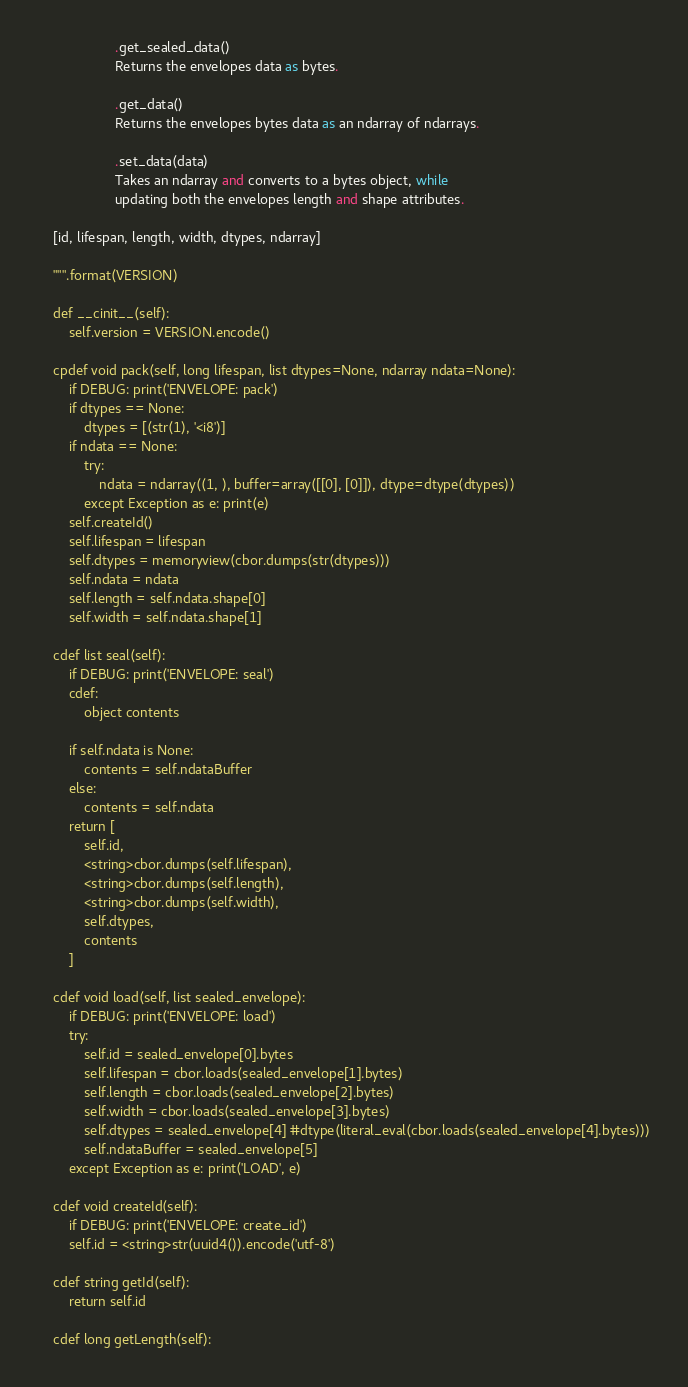<code> <loc_0><loc_0><loc_500><loc_500><_Cython_>                    .get_sealed_data()
                    Returns the envelopes data as bytes.

                    .get_data()
                    Returns the envelopes bytes data as an ndarray of ndarrays.

                    .set_data(data)
                    Takes an ndarray and converts to a bytes object, while 
                    updating both the envelopes length and shape attributes.

    [id, lifespan, length, width, dtypes, ndarray]

    """.format(VERSION)

    def __cinit__(self):
        self.version = VERSION.encode()

    cpdef void pack(self, long lifespan, list dtypes=None, ndarray ndata=None):
        if DEBUG: print('ENVELOPE: pack')
        if dtypes == None:
            dtypes = [(str(1), '<i8')]
        if ndata == None:
            try:
                ndata = ndarray((1, ), buffer=array([[0], [0]]), dtype=dtype(dtypes))
            except Exception as e: print(e)
        self.createId()
        self.lifespan = lifespan
        self.dtypes = memoryview(cbor.dumps(str(dtypes)))
        self.ndata = ndata
        self.length = self.ndata.shape[0]
        self.width = self.ndata.shape[1]

    cdef list seal(self):
        if DEBUG: print('ENVELOPE: seal')
        cdef:
            object contents

        if self.ndata is None:
            contents = self.ndataBuffer
        else:
            contents = self.ndata
        return [
            self.id,
            <string>cbor.dumps(self.lifespan),
            <string>cbor.dumps(self.length),
            <string>cbor.dumps(self.width),
            self.dtypes,
            contents
        ]

    cdef void load(self, list sealed_envelope):
        if DEBUG: print('ENVELOPE: load')
        try:
            self.id = sealed_envelope[0].bytes
            self.lifespan = cbor.loads(sealed_envelope[1].bytes)
            self.length = cbor.loads(sealed_envelope[2].bytes)
            self.width = cbor.loads(sealed_envelope[3].bytes)
            self.dtypes = sealed_envelope[4] #dtype(literal_eval(cbor.loads(sealed_envelope[4].bytes)))
            self.ndataBuffer = sealed_envelope[5]
        except Exception as e: print('LOAD', e)

    cdef void createId(self):
        if DEBUG: print('ENVELOPE: create_id')
        self.id = <string>str(uuid4()).encode('utf-8')

    cdef string getId(self):
        return self.id

    cdef long getLength(self):</code> 